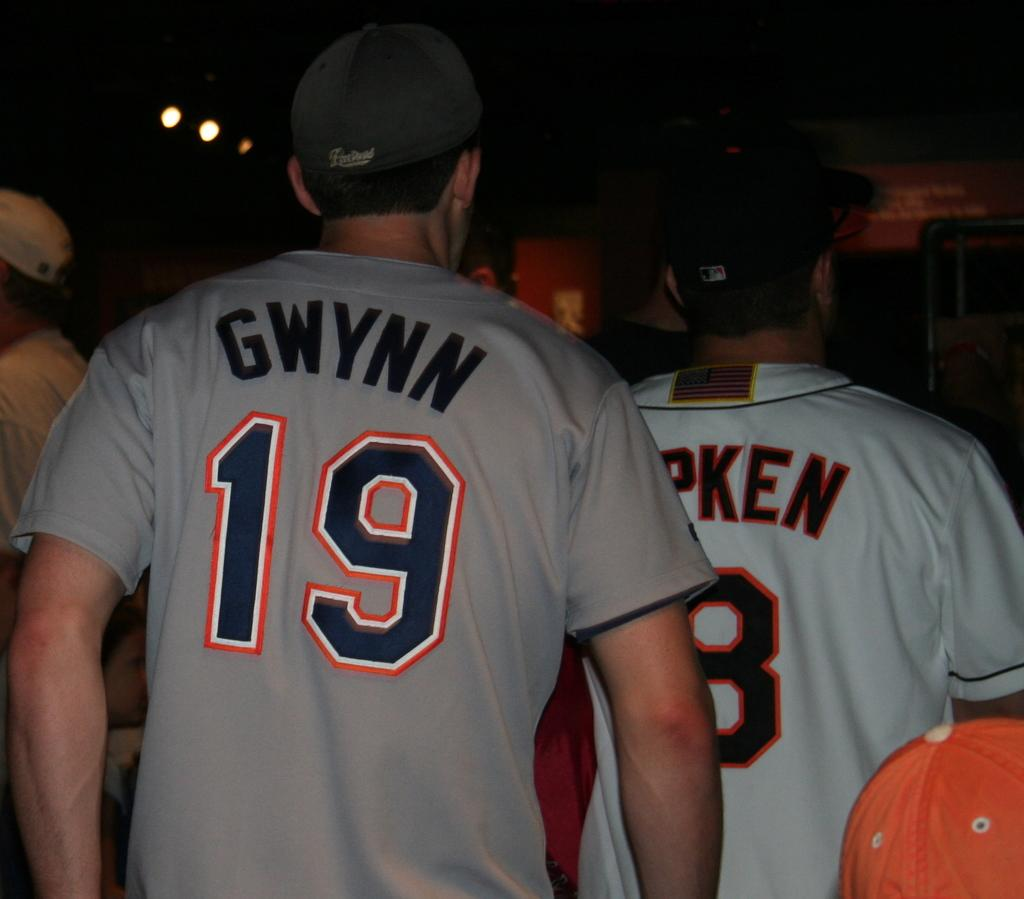<image>
Describe the image concisely. A man with the number 19 on his shirt 